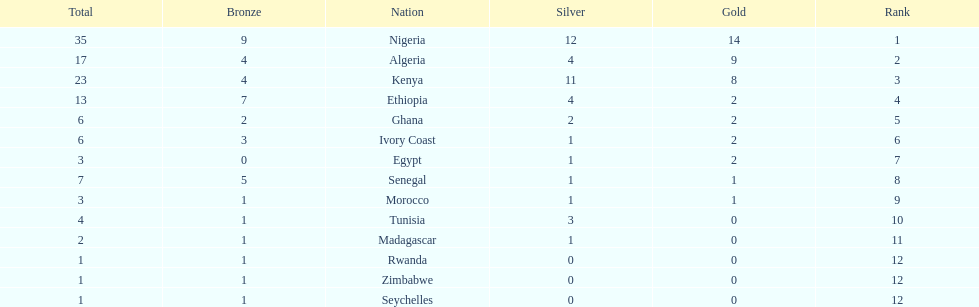What is the title of the sole country that didn't secure any bronze medals? Egypt. Give me the full table as a dictionary. {'header': ['Total', 'Bronze', 'Nation', 'Silver', 'Gold', 'Rank'], 'rows': [['35', '9', 'Nigeria', '12', '14', '1'], ['17', '4', 'Algeria', '4', '9', '2'], ['23', '4', 'Kenya', '11', '8', '3'], ['13', '7', 'Ethiopia', '4', '2', '4'], ['6', '2', 'Ghana', '2', '2', '5'], ['6', '3', 'Ivory Coast', '1', '2', '6'], ['3', '0', 'Egypt', '1', '2', '7'], ['7', '5', 'Senegal', '1', '1', '8'], ['3', '1', 'Morocco', '1', '1', '9'], ['4', '1', 'Tunisia', '3', '0', '10'], ['2', '1', 'Madagascar', '1', '0', '11'], ['1', '1', 'Rwanda', '0', '0', '12'], ['1', '1', 'Zimbabwe', '0', '0', '12'], ['1', '1', 'Seychelles', '0', '0', '12']]} 